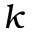<formula> <loc_0><loc_0><loc_500><loc_500>\boldsymbol k</formula> 